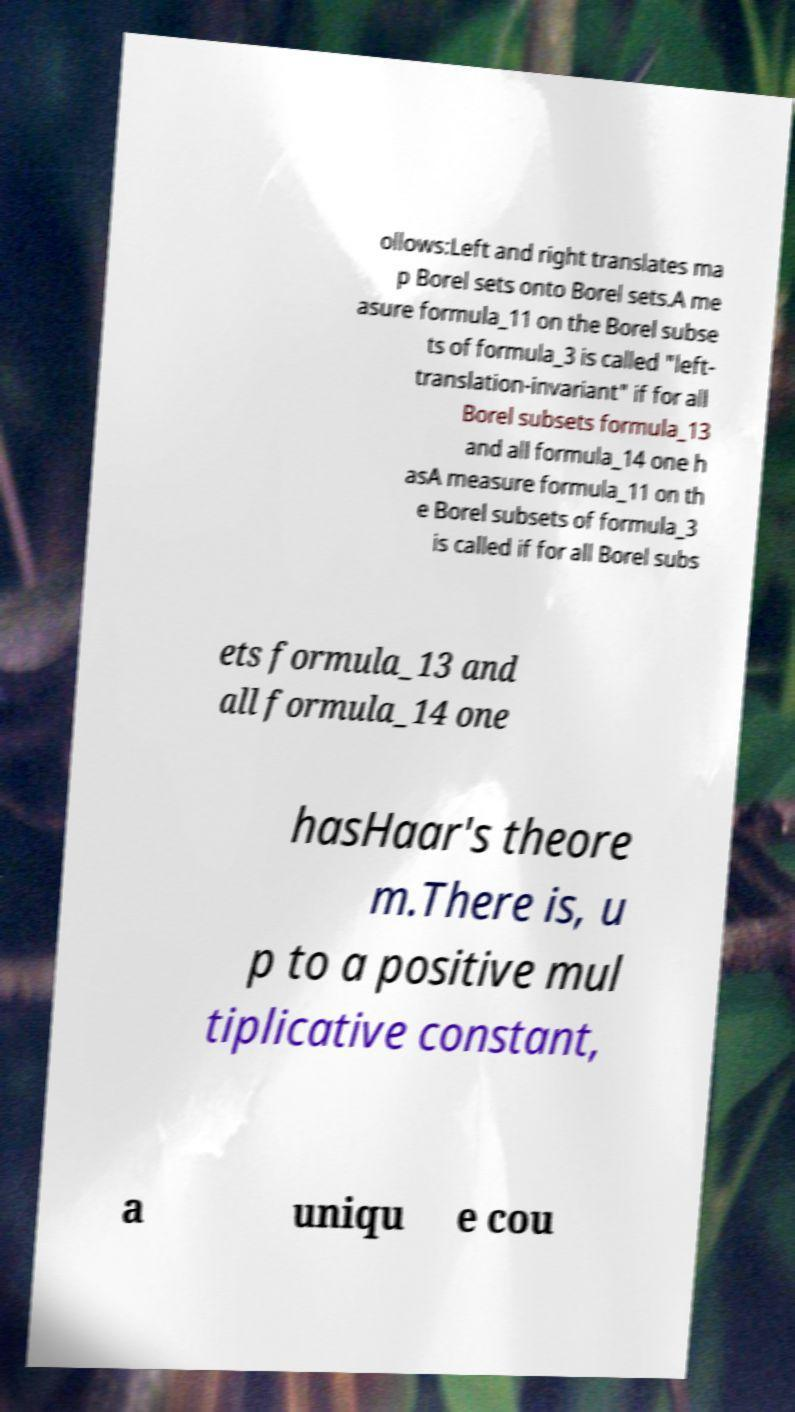There's text embedded in this image that I need extracted. Can you transcribe it verbatim? ollows:Left and right translates ma p Borel sets onto Borel sets.A me asure formula_11 on the Borel subse ts of formula_3 is called "left- translation-invariant" if for all Borel subsets formula_13 and all formula_14 one h asA measure formula_11 on th e Borel subsets of formula_3 is called if for all Borel subs ets formula_13 and all formula_14 one hasHaar's theore m.There is, u p to a positive mul tiplicative constant, a uniqu e cou 